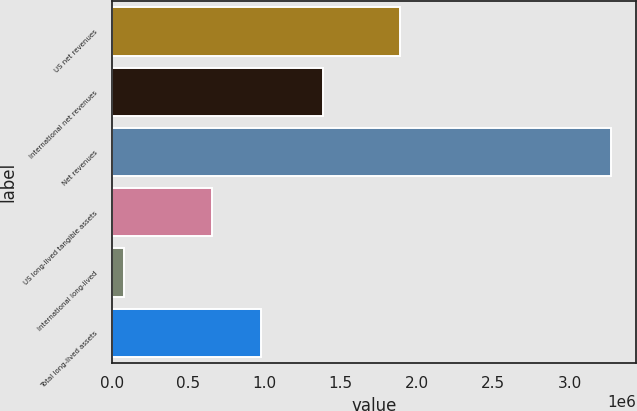Convert chart. <chart><loc_0><loc_0><loc_500><loc_500><bar_chart><fcel>US net revenues<fcel>International net revenues<fcel>Net revenues<fcel>US long-lived tangible assets<fcel>International long-lived<fcel>Total long-lived assets<nl><fcel>1.88994e+06<fcel>1.38137e+06<fcel>3.27131e+06<fcel>659423<fcel>80069<fcel>978547<nl></chart> 